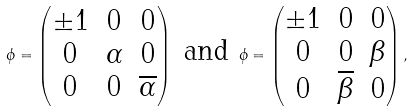Convert formula to latex. <formula><loc_0><loc_0><loc_500><loc_500>\phi = \left ( \begin{matrix} \pm 1 & 0 & 0 \\ 0 & \alpha & 0 \\ 0 & 0 & \overline { \alpha } \end{matrix} \right ) \ \text {and} \ \phi = \left ( \begin{matrix} \pm 1 & 0 & 0 \\ 0 & 0 & \beta \\ 0 & \overline { \beta } & 0 \end{matrix} \right ) ,</formula> 